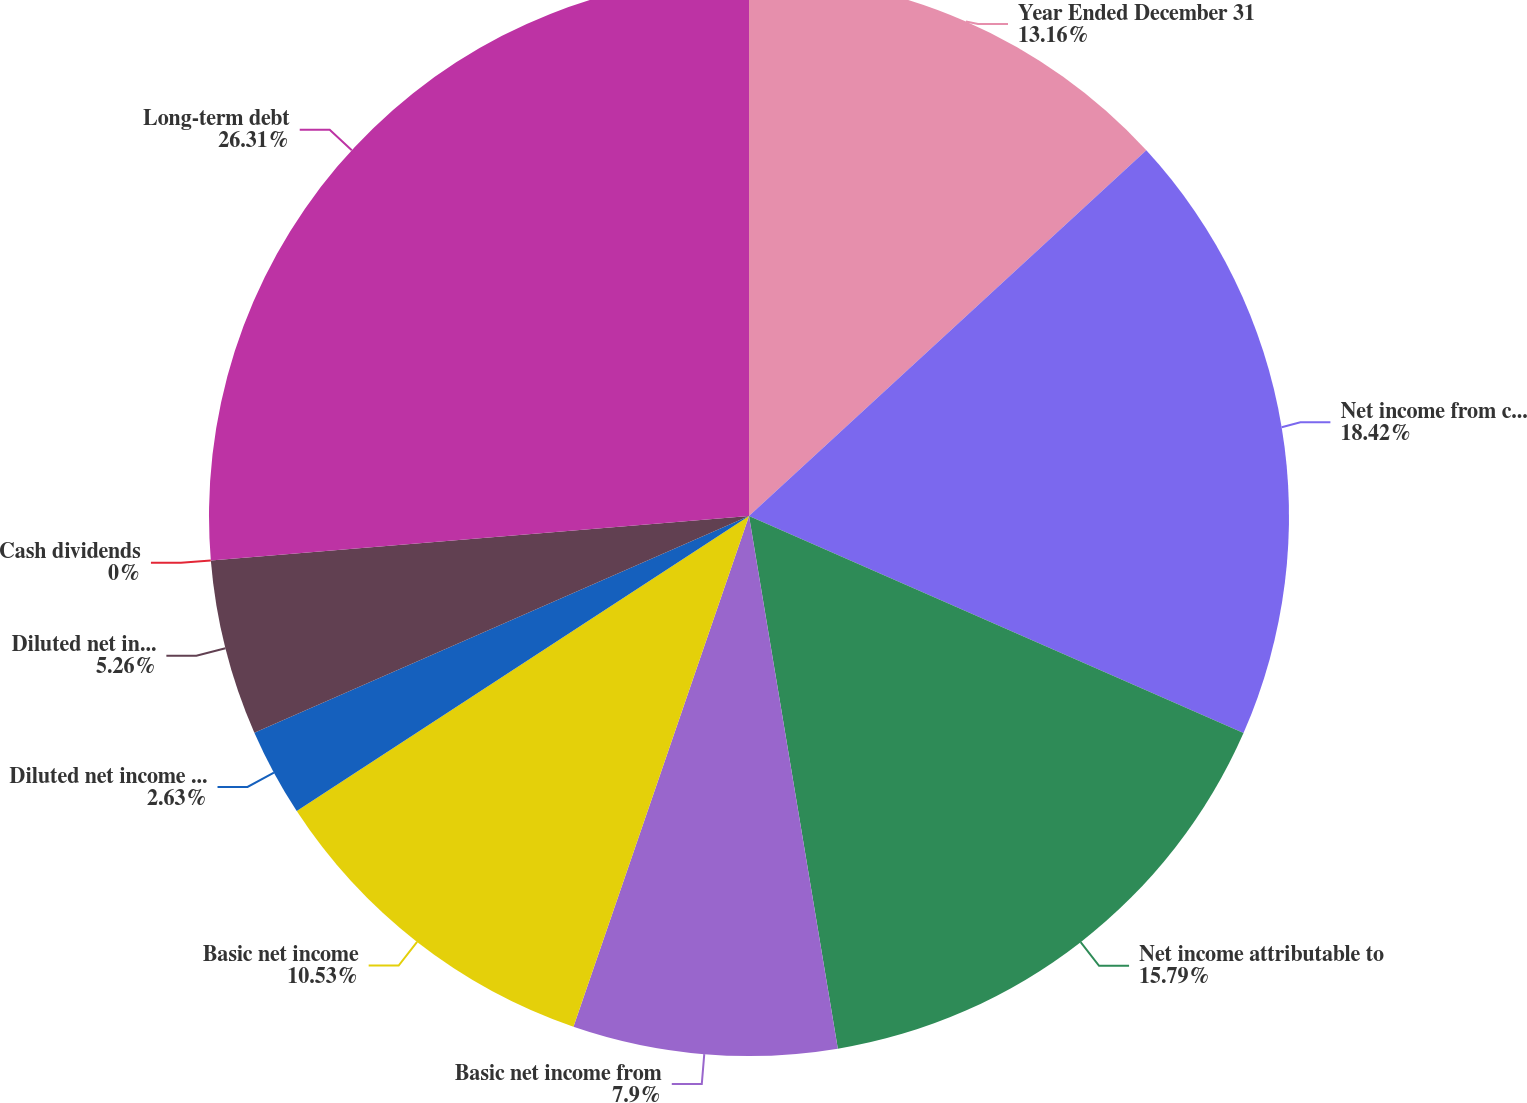<chart> <loc_0><loc_0><loc_500><loc_500><pie_chart><fcel>Year Ended December 31<fcel>Net income from continuing<fcel>Net income attributable to<fcel>Basic net income from<fcel>Basic net income<fcel>Diluted net income from<fcel>Diluted net income<fcel>Cash dividends<fcel>Long-term debt<nl><fcel>13.16%<fcel>18.42%<fcel>15.79%<fcel>7.9%<fcel>10.53%<fcel>2.63%<fcel>5.26%<fcel>0.0%<fcel>26.31%<nl></chart> 